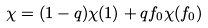<formula> <loc_0><loc_0><loc_500><loc_500>\chi = ( 1 - q ) \chi ( 1 ) + q f _ { 0 } \chi ( f _ { 0 } )</formula> 